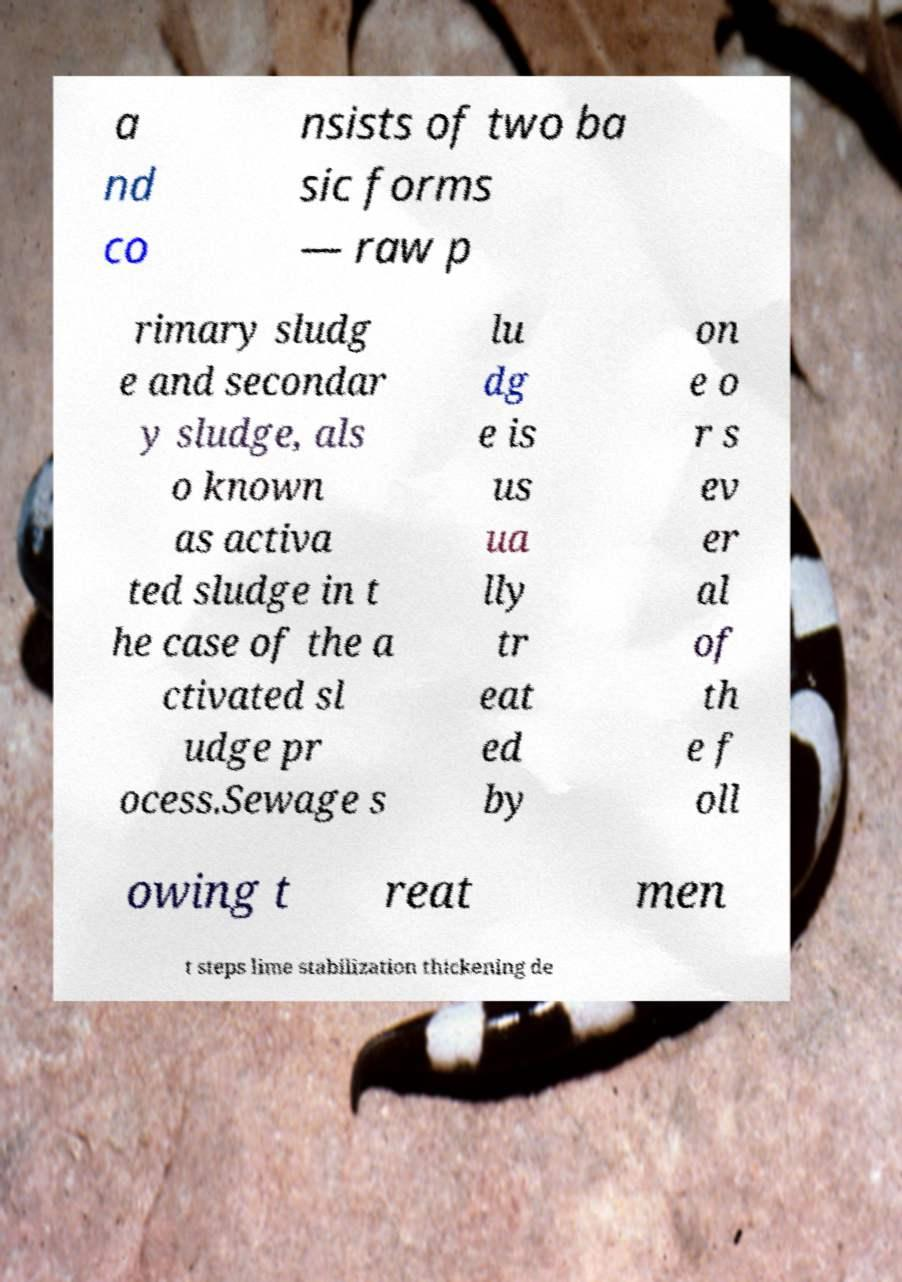Could you extract and type out the text from this image? a nd co nsists of two ba sic forms — raw p rimary sludg e and secondar y sludge, als o known as activa ted sludge in t he case of the a ctivated sl udge pr ocess.Sewage s lu dg e is us ua lly tr eat ed by on e o r s ev er al of th e f oll owing t reat men t steps lime stabilization thickening de 